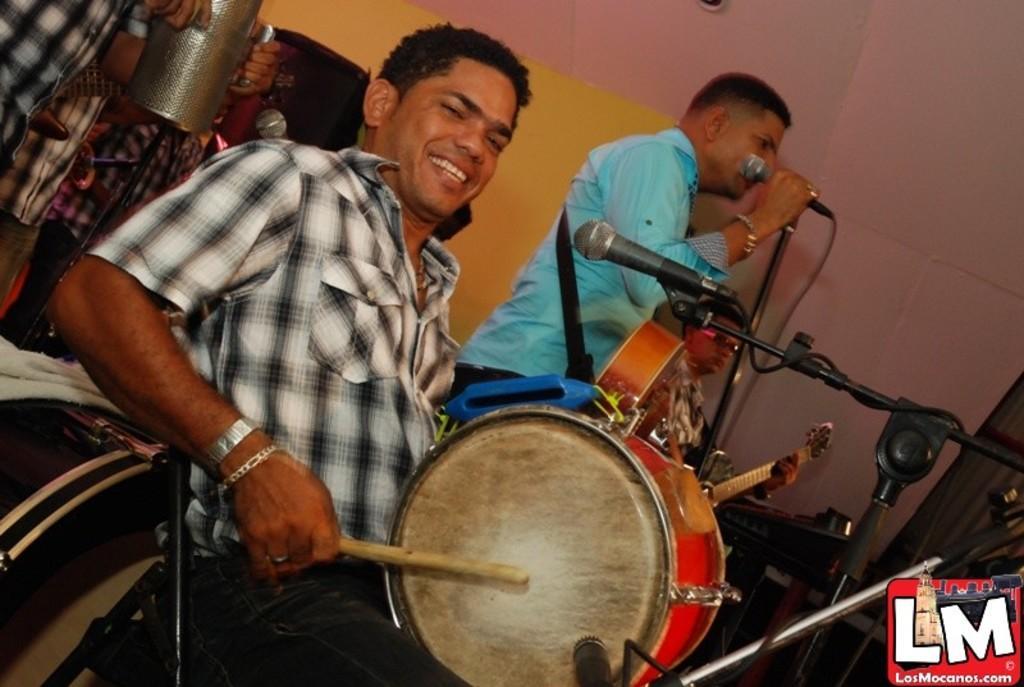Could you give a brief overview of what you see in this image? This image is clicked inside the room. There are four people in the image. In the front, the man is wearing black and white shirt, is playing drums. To the back, the man wearing blue shirt, is playing the guitar and singing in mic. In the background there is wall. 